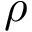<formula> <loc_0><loc_0><loc_500><loc_500>\rho</formula> 